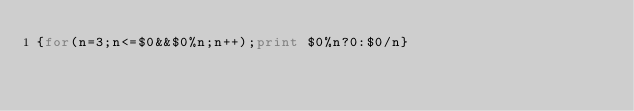Convert code to text. <code><loc_0><loc_0><loc_500><loc_500><_Awk_>{for(n=3;n<=$0&&$0%n;n++);print $0%n?0:$0/n}</code> 